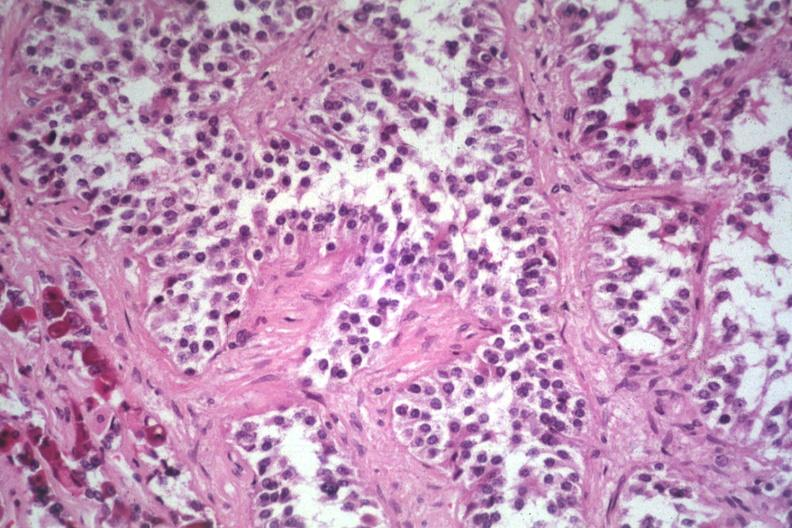s amyloidosis present?
Answer the question using a single word or phrase. No 